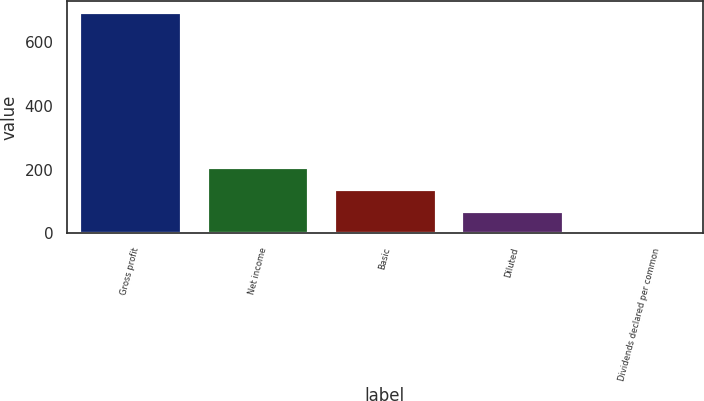Convert chart. <chart><loc_0><loc_0><loc_500><loc_500><bar_chart><fcel>Gross profit<fcel>Net income<fcel>Basic<fcel>Diluted<fcel>Dividends declared per common<nl><fcel>695.2<fcel>208.61<fcel>139.09<fcel>69.57<fcel>0.05<nl></chart> 